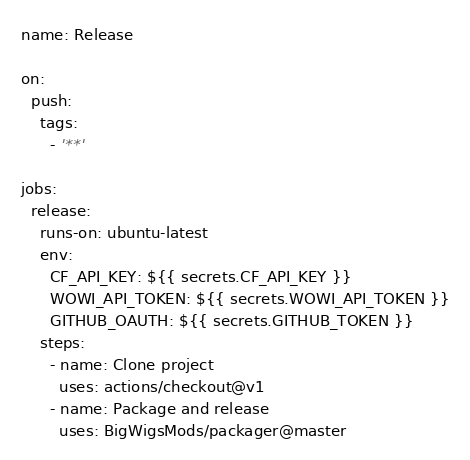Convert code to text. <code><loc_0><loc_0><loc_500><loc_500><_YAML_>name: Release

on:
  push:
    tags:
      - '**'

jobs:
  release:
    runs-on: ubuntu-latest
    env:
      CF_API_KEY: ${{ secrets.CF_API_KEY }}
      WOWI_API_TOKEN: ${{ secrets.WOWI_API_TOKEN }}
      GITHUB_OAUTH: ${{ secrets.GITHUB_TOKEN }} 
    steps:
      - name: Clone project
        uses: actions/checkout@v1
      - name: Package and release
        uses: BigWigsMods/packager@master</code> 